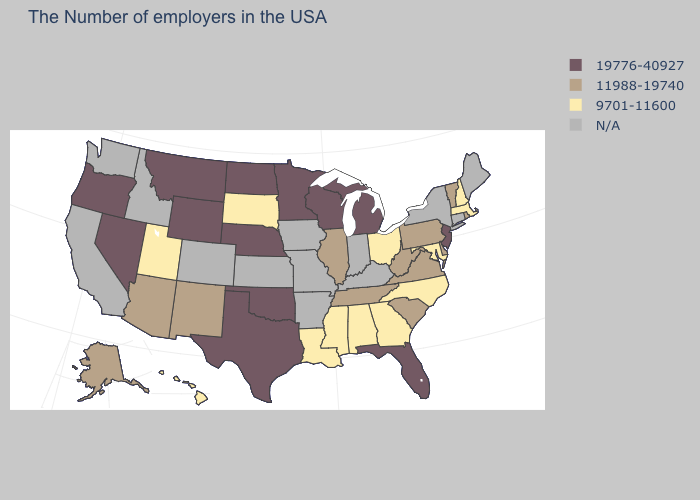What is the highest value in states that border Maryland?
Quick response, please. 11988-19740. Name the states that have a value in the range 9701-11600?
Answer briefly. Massachusetts, New Hampshire, Maryland, North Carolina, Ohio, Georgia, Alabama, Mississippi, Louisiana, South Dakota, Utah, Hawaii. What is the value of Oregon?
Concise answer only. 19776-40927. Does the map have missing data?
Answer briefly. Yes. Name the states that have a value in the range 11988-19740?
Be succinct. Rhode Island, Vermont, Delaware, Pennsylvania, Virginia, South Carolina, West Virginia, Tennessee, Illinois, New Mexico, Arizona, Alaska. Name the states that have a value in the range 11988-19740?
Concise answer only. Rhode Island, Vermont, Delaware, Pennsylvania, Virginia, South Carolina, West Virginia, Tennessee, Illinois, New Mexico, Arizona, Alaska. Among the states that border Alabama , which have the lowest value?
Answer briefly. Georgia, Mississippi. Name the states that have a value in the range 9701-11600?
Concise answer only. Massachusetts, New Hampshire, Maryland, North Carolina, Ohio, Georgia, Alabama, Mississippi, Louisiana, South Dakota, Utah, Hawaii. Name the states that have a value in the range 19776-40927?
Be succinct. New Jersey, Florida, Michigan, Wisconsin, Minnesota, Nebraska, Oklahoma, Texas, North Dakota, Wyoming, Montana, Nevada, Oregon. What is the lowest value in the Northeast?
Write a very short answer. 9701-11600. Name the states that have a value in the range 11988-19740?
Write a very short answer. Rhode Island, Vermont, Delaware, Pennsylvania, Virginia, South Carolina, West Virginia, Tennessee, Illinois, New Mexico, Arizona, Alaska. What is the value of Nevada?
Answer briefly. 19776-40927. Name the states that have a value in the range 11988-19740?
Quick response, please. Rhode Island, Vermont, Delaware, Pennsylvania, Virginia, South Carolina, West Virginia, Tennessee, Illinois, New Mexico, Arizona, Alaska. Among the states that border Wisconsin , does Illinois have the lowest value?
Quick response, please. Yes. 